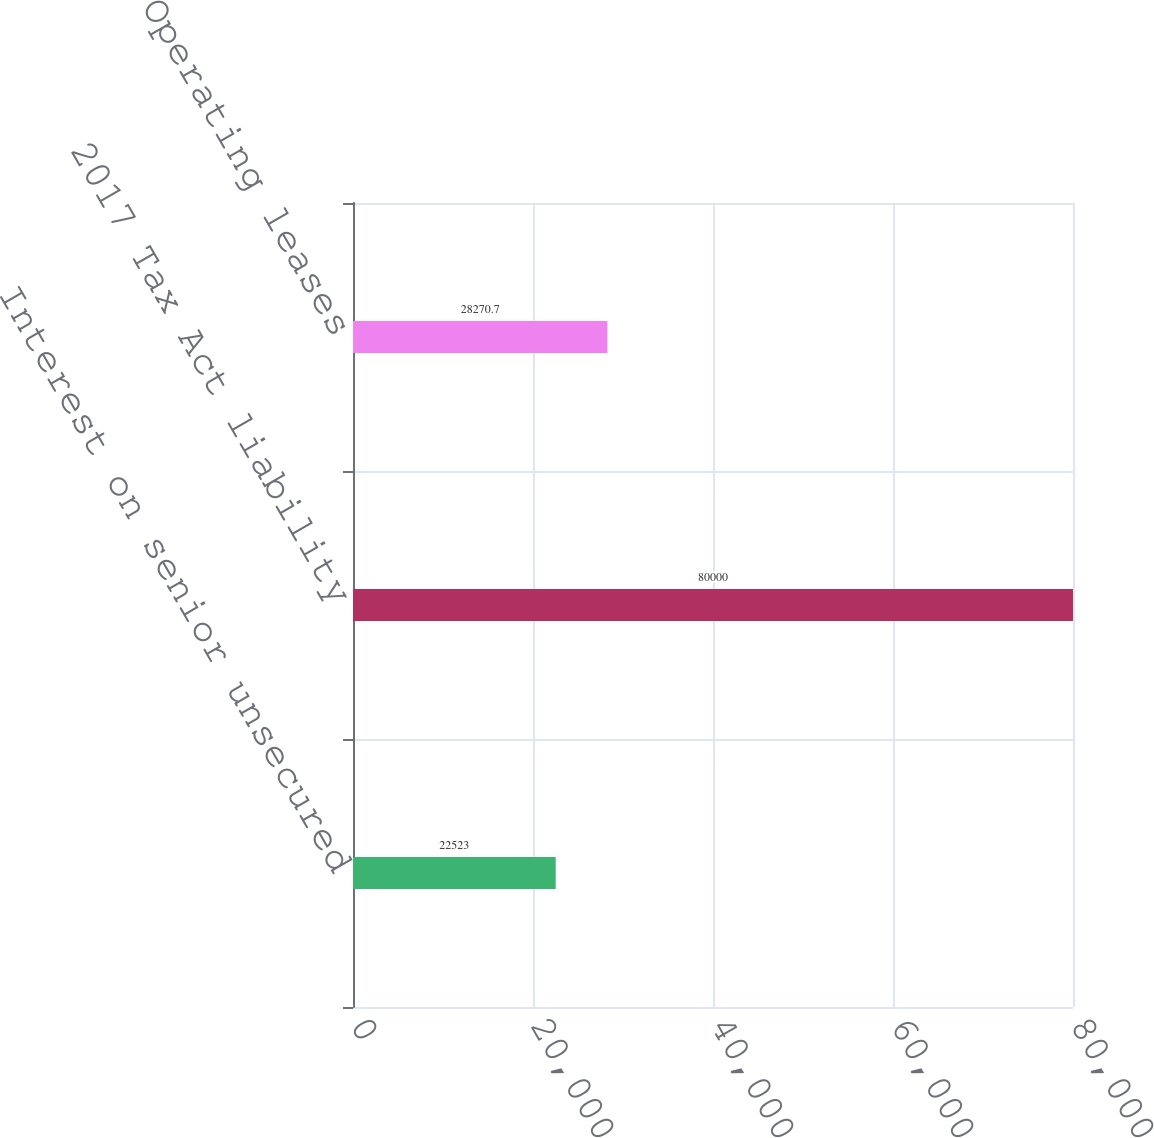Convert chart to OTSL. <chart><loc_0><loc_0><loc_500><loc_500><bar_chart><fcel>Interest on senior unsecured<fcel>2017 Tax Act liability<fcel>Operating leases<nl><fcel>22523<fcel>80000<fcel>28270.7<nl></chart> 